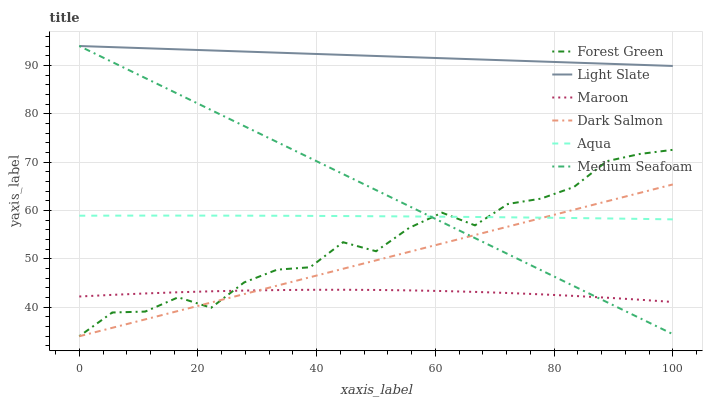Does Maroon have the minimum area under the curve?
Answer yes or no. Yes. Does Light Slate have the maximum area under the curve?
Answer yes or no. Yes. Does Aqua have the minimum area under the curve?
Answer yes or no. No. Does Aqua have the maximum area under the curve?
Answer yes or no. No. Is Dark Salmon the smoothest?
Answer yes or no. Yes. Is Forest Green the roughest?
Answer yes or no. Yes. Is Aqua the smoothest?
Answer yes or no. No. Is Aqua the roughest?
Answer yes or no. No. Does Dark Salmon have the lowest value?
Answer yes or no. Yes. Does Aqua have the lowest value?
Answer yes or no. No. Does Medium Seafoam have the highest value?
Answer yes or no. Yes. Does Aqua have the highest value?
Answer yes or no. No. Is Aqua less than Light Slate?
Answer yes or no. Yes. Is Aqua greater than Maroon?
Answer yes or no. Yes. Does Aqua intersect Forest Green?
Answer yes or no. Yes. Is Aqua less than Forest Green?
Answer yes or no. No. Is Aqua greater than Forest Green?
Answer yes or no. No. Does Aqua intersect Light Slate?
Answer yes or no. No. 